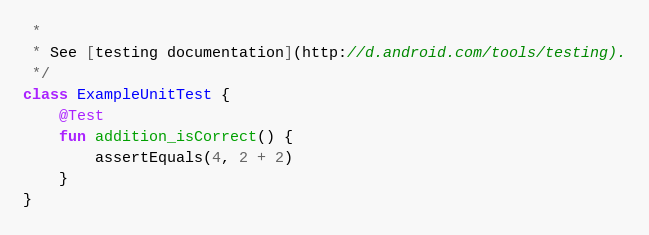Convert code to text. <code><loc_0><loc_0><loc_500><loc_500><_Kotlin_> *
 * See [testing documentation](http://d.android.com/tools/testing).
 */
class ExampleUnitTest {
    @Test
    fun addition_isCorrect() {
        assertEquals(4, 2 + 2)
    }
}</code> 